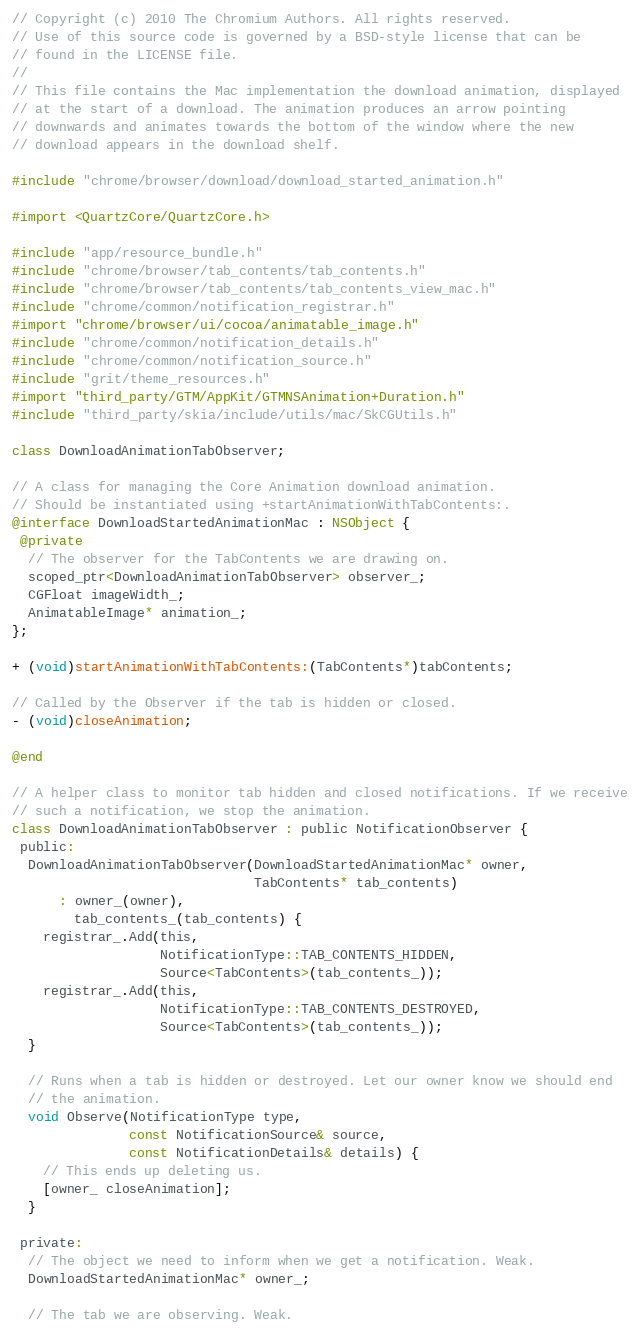Convert code to text. <code><loc_0><loc_0><loc_500><loc_500><_ObjectiveC_>// Copyright (c) 2010 The Chromium Authors. All rights reserved.
// Use of this source code is governed by a BSD-style license that can be
// found in the LICENSE file.
//
// This file contains the Mac implementation the download animation, displayed
// at the start of a download. The animation produces an arrow pointing
// downwards and animates towards the bottom of the window where the new
// download appears in the download shelf.

#include "chrome/browser/download/download_started_animation.h"

#import <QuartzCore/QuartzCore.h>

#include "app/resource_bundle.h"
#include "chrome/browser/tab_contents/tab_contents.h"
#include "chrome/browser/tab_contents/tab_contents_view_mac.h"
#include "chrome/common/notification_registrar.h"
#import "chrome/browser/ui/cocoa/animatable_image.h"
#include "chrome/common/notification_details.h"
#include "chrome/common/notification_source.h"
#include "grit/theme_resources.h"
#import "third_party/GTM/AppKit/GTMNSAnimation+Duration.h"
#include "third_party/skia/include/utils/mac/SkCGUtils.h"

class DownloadAnimationTabObserver;

// A class for managing the Core Animation download animation.
// Should be instantiated using +startAnimationWithTabContents:.
@interface DownloadStartedAnimationMac : NSObject {
 @private
  // The observer for the TabContents we are drawing on.
  scoped_ptr<DownloadAnimationTabObserver> observer_;
  CGFloat imageWidth_;
  AnimatableImage* animation_;
};

+ (void)startAnimationWithTabContents:(TabContents*)tabContents;

// Called by the Observer if the tab is hidden or closed.
- (void)closeAnimation;

@end

// A helper class to monitor tab hidden and closed notifications. If we receive
// such a notification, we stop the animation.
class DownloadAnimationTabObserver : public NotificationObserver {
 public:
  DownloadAnimationTabObserver(DownloadStartedAnimationMac* owner,
                               TabContents* tab_contents)
      : owner_(owner),
        tab_contents_(tab_contents) {
    registrar_.Add(this,
                   NotificationType::TAB_CONTENTS_HIDDEN,
                   Source<TabContents>(tab_contents_));
    registrar_.Add(this,
                   NotificationType::TAB_CONTENTS_DESTROYED,
                   Source<TabContents>(tab_contents_));
  }

  // Runs when a tab is hidden or destroyed. Let our owner know we should end
  // the animation.
  void Observe(NotificationType type,
               const NotificationSource& source,
               const NotificationDetails& details) {
    // This ends up deleting us.
    [owner_ closeAnimation];
  }

 private:
  // The object we need to inform when we get a notification. Weak.
  DownloadStartedAnimationMac* owner_;

  // The tab we are observing. Weak.</code> 